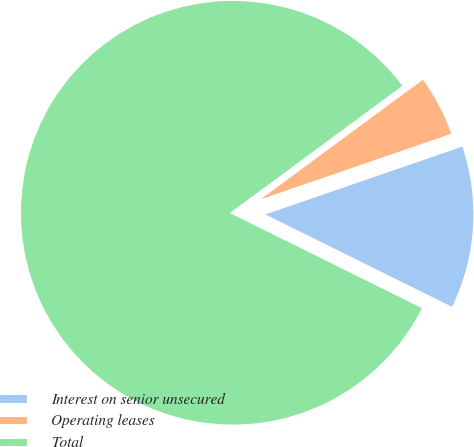Convert chart to OTSL. <chart><loc_0><loc_0><loc_500><loc_500><pie_chart><fcel>Interest on senior unsecured<fcel>Operating leases<fcel>Total<nl><fcel>12.6%<fcel>4.83%<fcel>82.57%<nl></chart> 